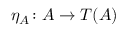<formula> <loc_0><loc_0><loc_500><loc_500>\eta _ { A } \colon A \to T ( A )</formula> 